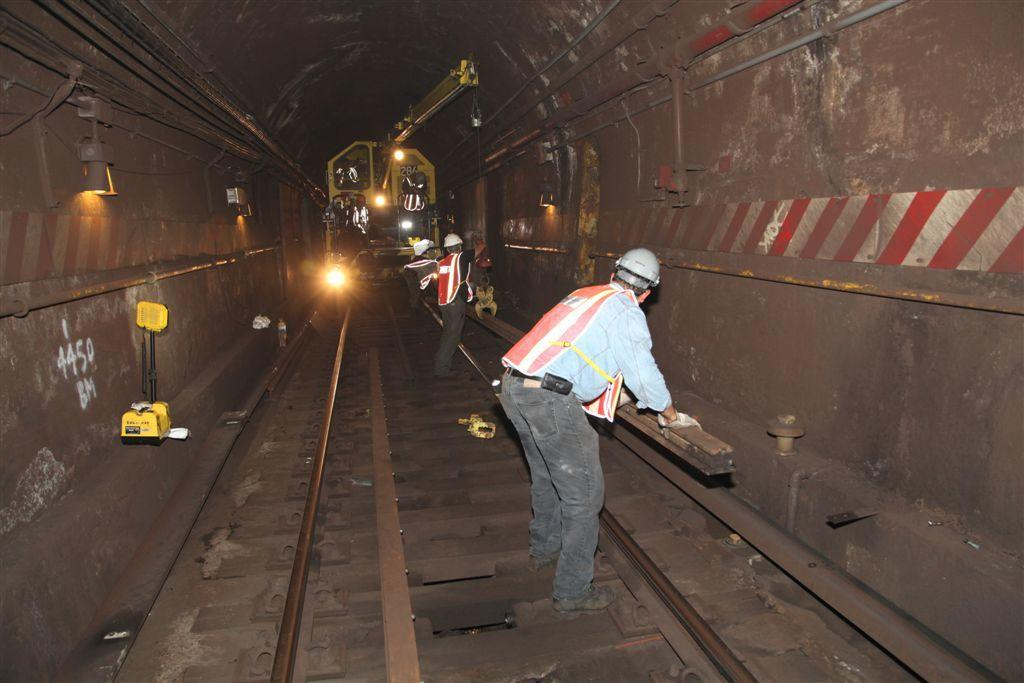Who is present in the image? There are people in the image. What are the people doing in the image? The people are working on a railway track. What type of alley can be seen in the background of the image? There is no alley present in the image; it features people working on a railway track. What color is the ink used by the people in the image? There is no ink present in the image; the people are working on a railway track. 